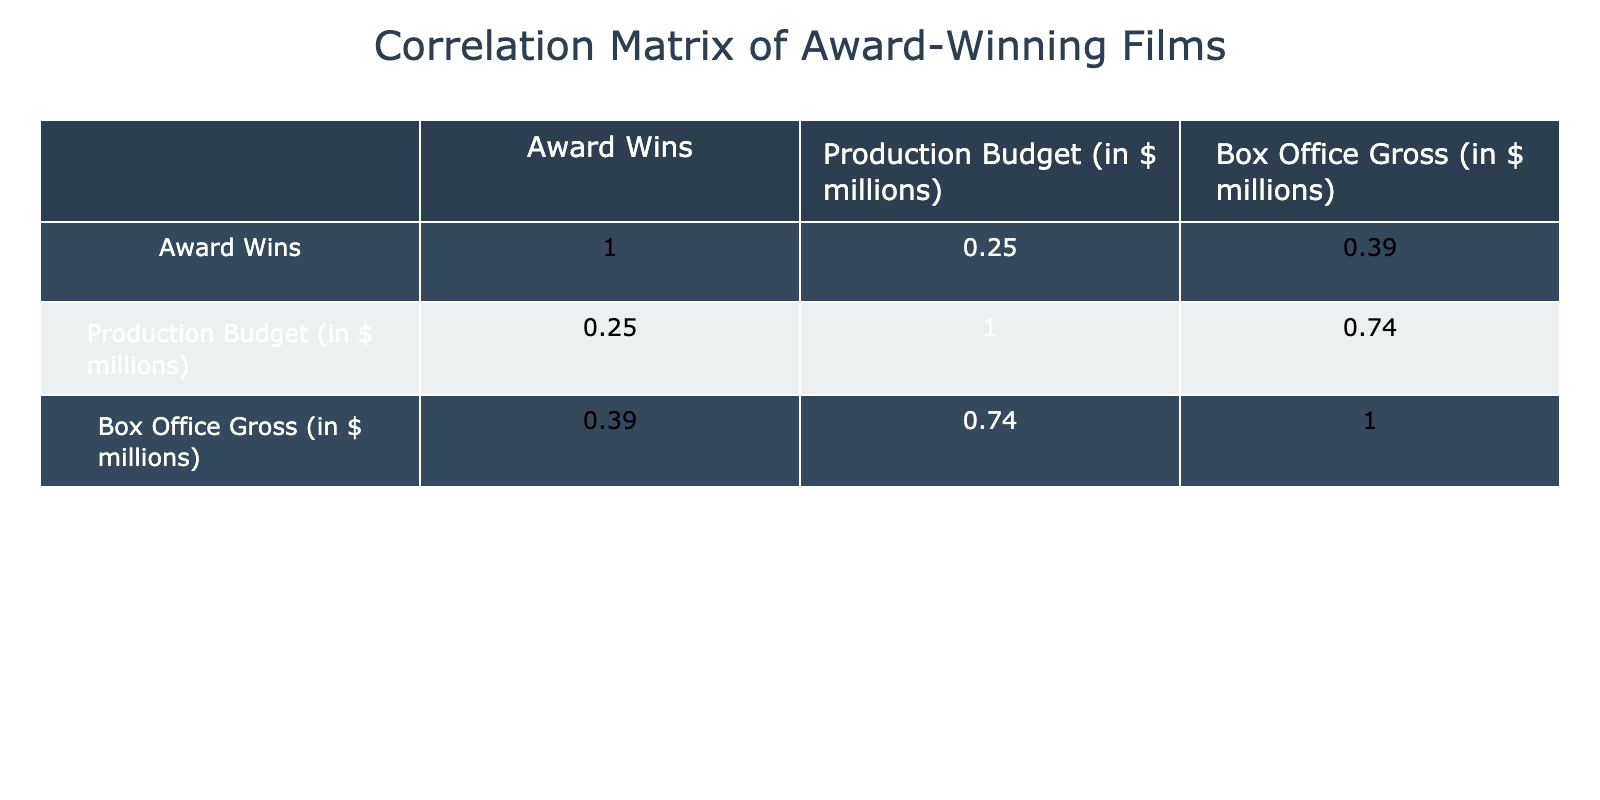What is the correlation coefficient between Box Office Gross and Production Budget? According to the correlation matrix, the correlation coefficient between Box Office Gross and Production Budget is 0.85. This indicates a strong positive relationship, meaning that as the production budget increases, the box office gross tends to increase as well.
Answer: 0.85 What was the Box Office Gross for the film "La La Land"? Referring to the table, the Box Office Gross for "La La Land" is 446 million dollars.
Answer: 446 Is there any film with a production budget of less than 10 million that won an award? From the table, "Moonlight" has a production budget of 1.5 million and it did win 3 awards. Thus, the statement is true.
Answer: Yes What is the average Box Office Gross for films that won 3 awards? The films that won 3 awards are "Moonlight", "12 Years a Slave", "Green Book", and "Nomadland". Their Box Office Gross amounts are 65, 187, 324, and 39 respectively. To find the average, sum these values (65 + 187 + 324 + 39 = 615) and divide by 4, which gives us an average of 153.75 million dollars.
Answer: 153.75 Which film had the highest Box Office Gross and what was its corresponding Production Budget? Looking through the table, "La La Land" has the highest Box Office Gross at 446 million, and its corresponding Production Budget is 30 million.
Answer: "La La Land", 30 What is the correlation coefficient between Award Wins and Box Office Gross? The correlation matrix shows the correlation coefficient between Award Wins and Box Office Gross is 0.63, indicating a moderate positive relationship. This suggests that films that win more awards tend to also perform better at the box office.
Answer: 0.63 Did "Birdman" have a higher Box Office Gross than "The Shape of Water"? Checking the values, "Birdman" had a Box Office Gross of 103 million, while "The Shape of Water" had a Box Office Gross of 195 million. Therefore, it is false that "Birdman" had a higher gross.
Answer: No What is the total Production Budget of films that won more than 5 awards? The only film on the list that won more than 5 awards is "Everything Everywhere All at Once" with a Production Budget of 14 million. Therefore, the total Production Budget for films with more than 5 awards is 14 million.
Answer: 14 